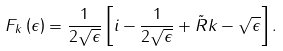<formula> <loc_0><loc_0><loc_500><loc_500>F _ { k } \left ( \epsilon \right ) = \frac { 1 } { 2 \sqrt { \epsilon } } \left [ i - \frac { 1 } { 2 \sqrt { \epsilon } } + \tilde { R } k - \sqrt { \epsilon } \right ] .</formula> 